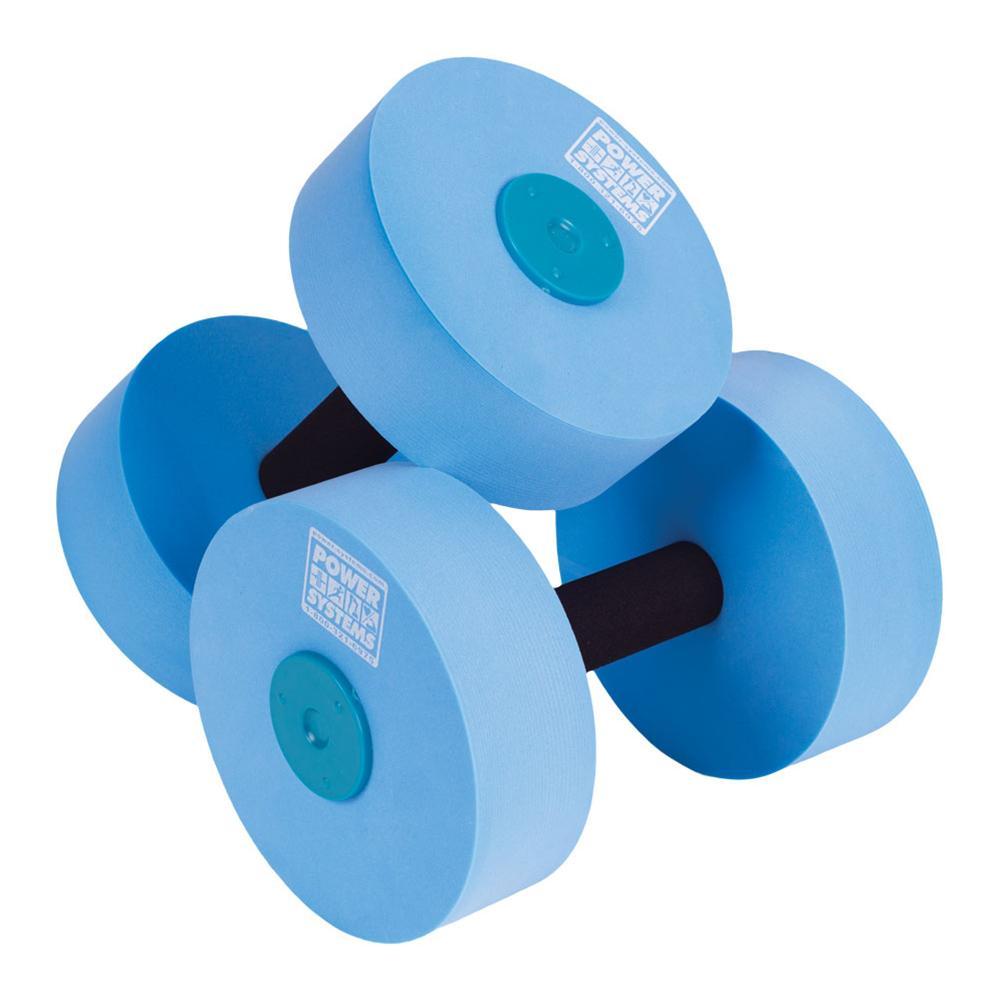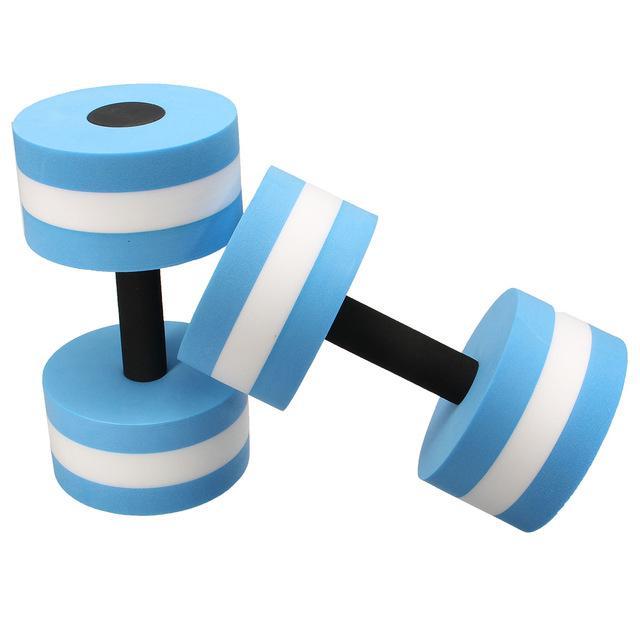The first image is the image on the left, the second image is the image on the right. Evaluate the accuracy of this statement regarding the images: "There are four blue water dumbbell with only two that have white stripes on it.". Is it true? Answer yes or no. Yes. The first image is the image on the left, the second image is the image on the right. For the images shown, is this caption "Four or fewer dumb bells are visible." true? Answer yes or no. Yes. 